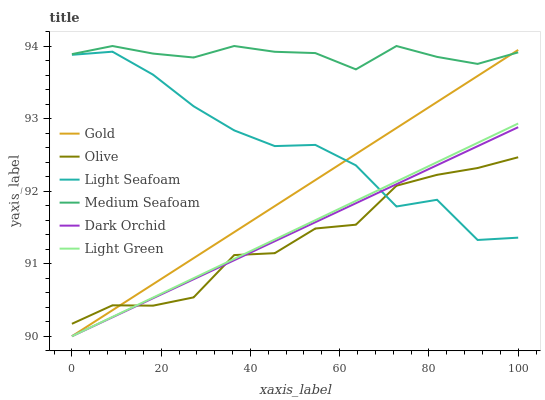Does Dark Orchid have the minimum area under the curve?
Answer yes or no. No. Does Dark Orchid have the maximum area under the curve?
Answer yes or no. No. Is Light Green the smoothest?
Answer yes or no. No. Is Light Green the roughest?
Answer yes or no. No. Does Olive have the lowest value?
Answer yes or no. No. Does Dark Orchid have the highest value?
Answer yes or no. No. Is Light Green less than Medium Seafoam?
Answer yes or no. Yes. Is Medium Seafoam greater than Dark Orchid?
Answer yes or no. Yes. Does Light Green intersect Medium Seafoam?
Answer yes or no. No. 